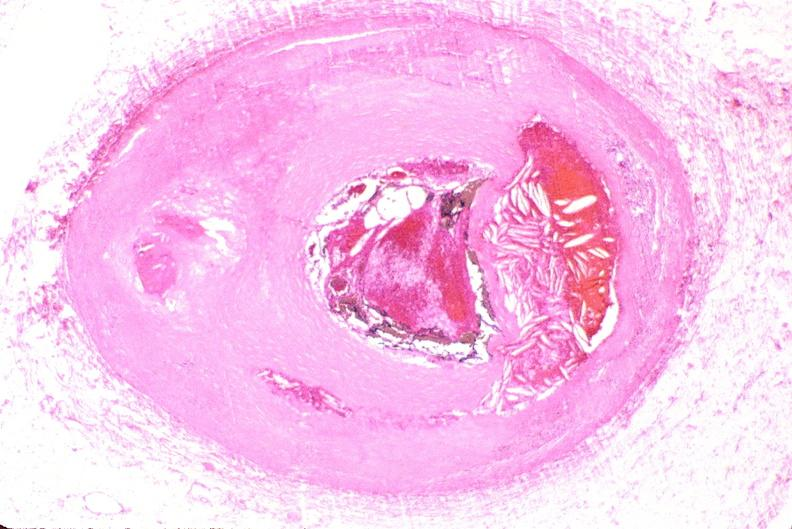s vasculature present?
Answer the question using a single word or phrase. Yes 